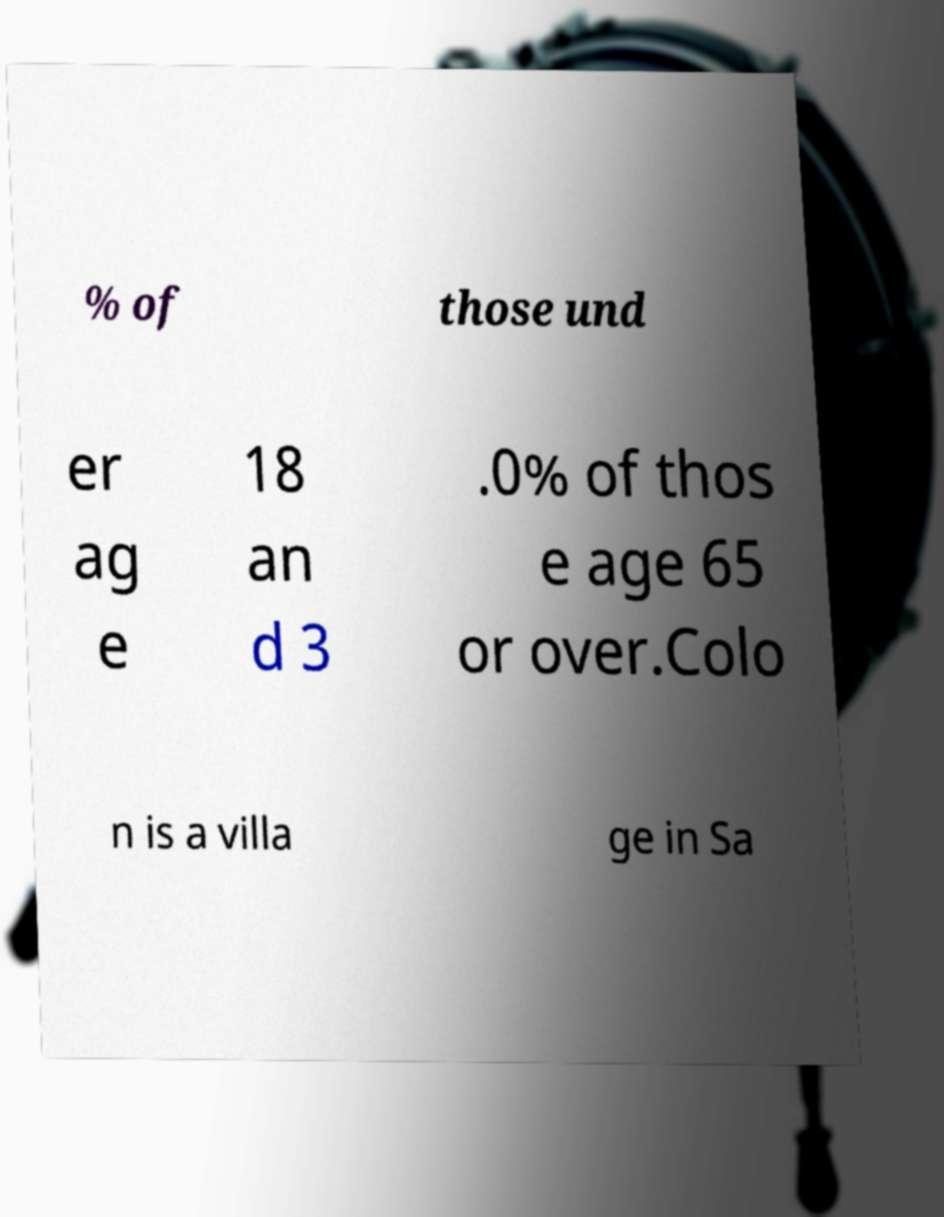Please read and relay the text visible in this image. What does it say? % of those und er ag e 18 an d 3 .0% of thos e age 65 or over.Colo n is a villa ge in Sa 